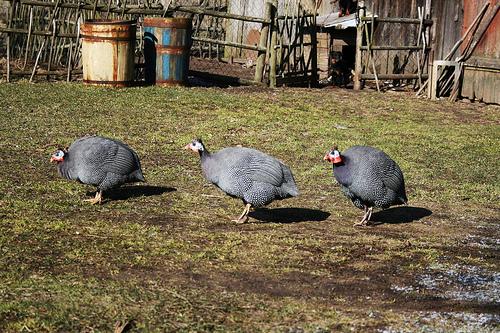Are these some underfed looking specimens?
Write a very short answer. No. How many birds are there?
Concise answer only. 3. What color is the barrel on the right?
Answer briefly. Blue. 